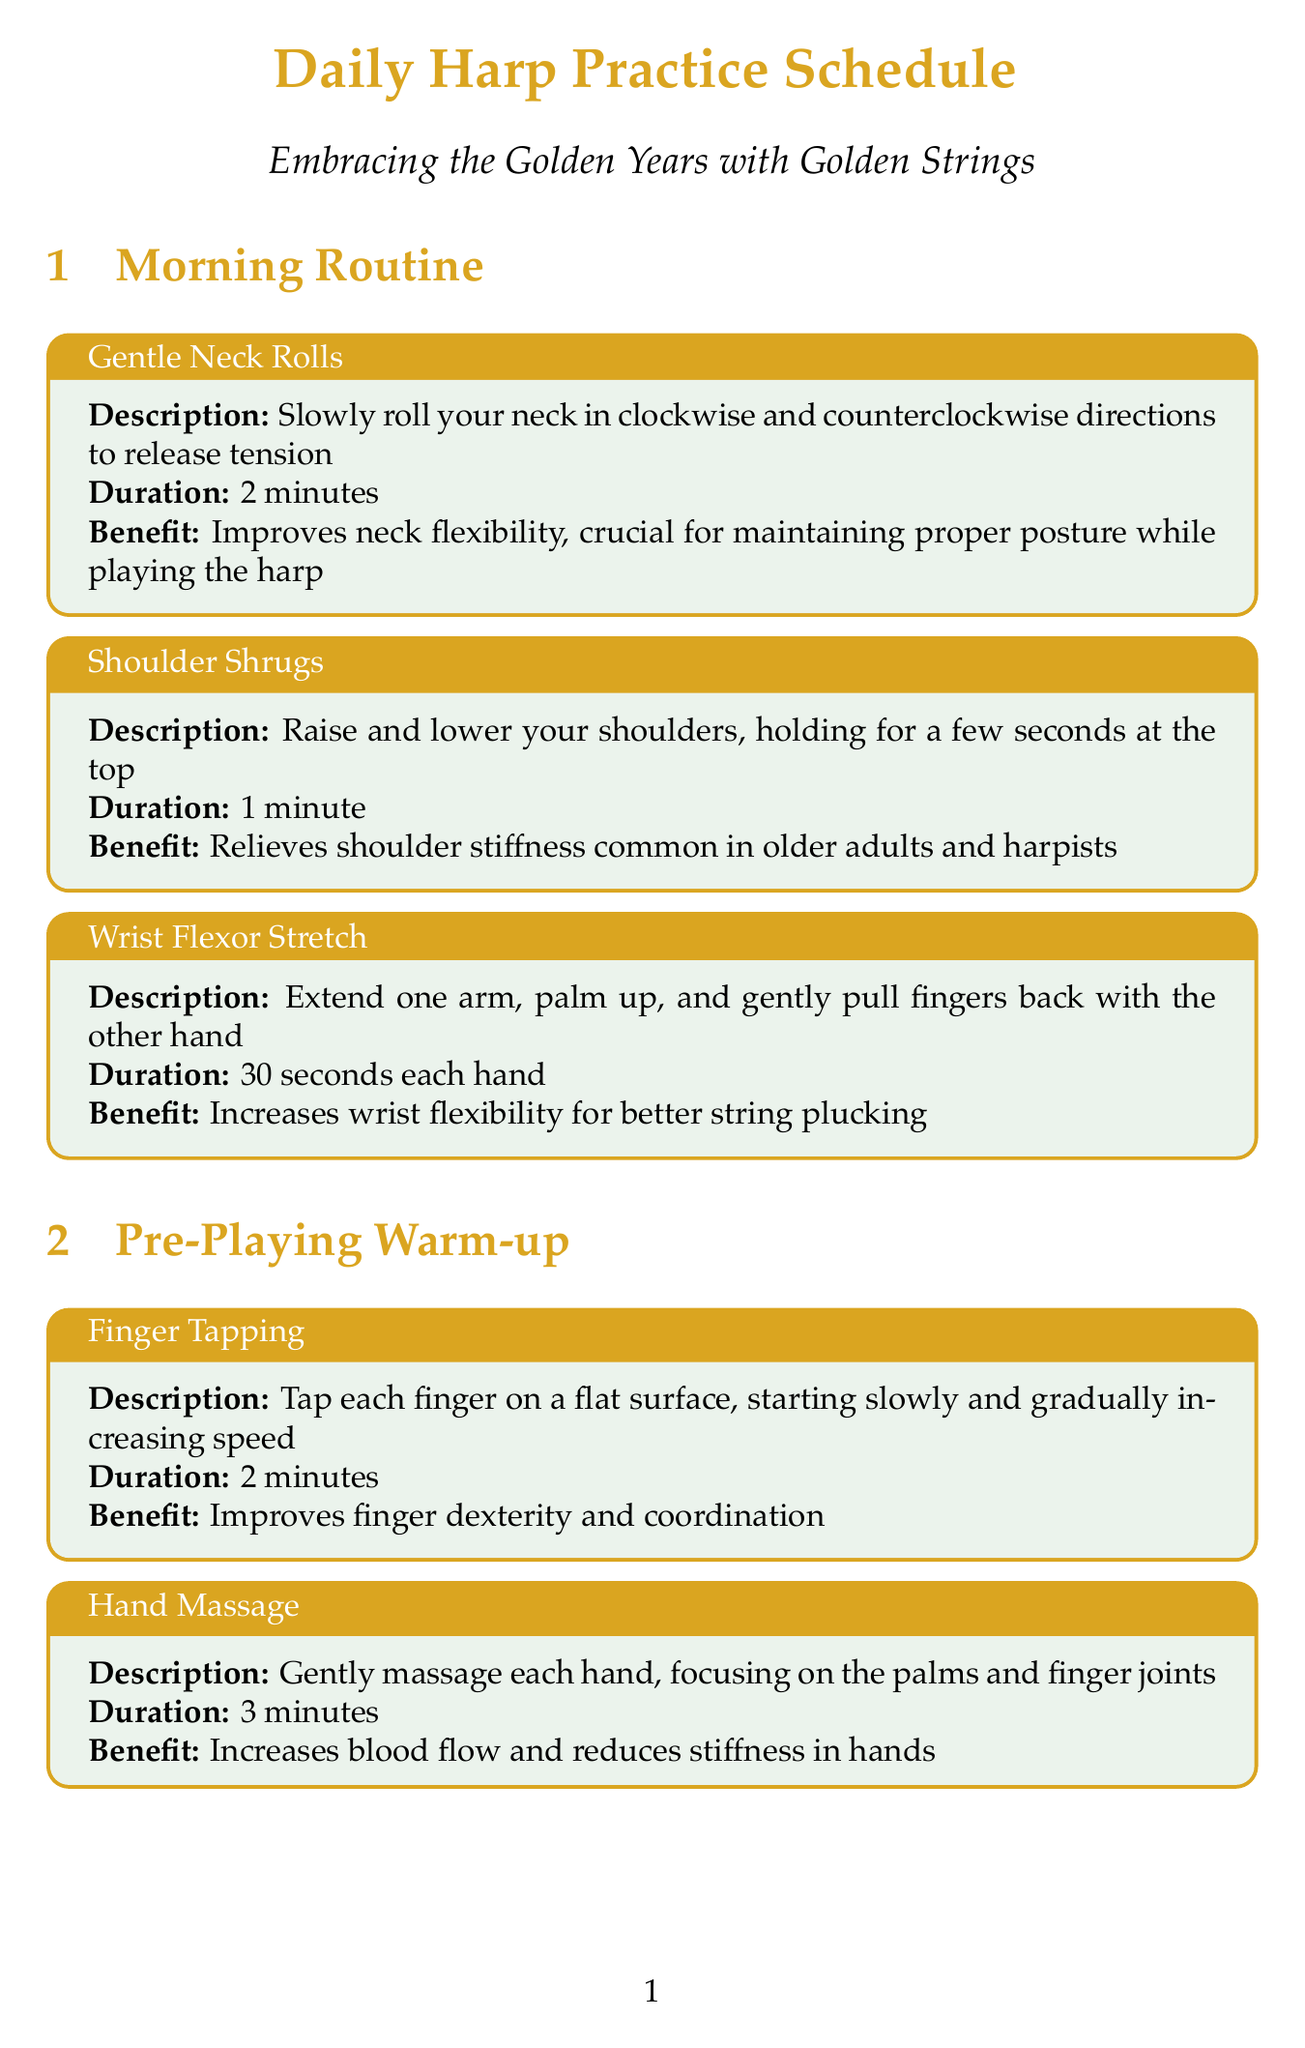What is the duration of Shoulder Shrugs? The document provides specific durations for each exercise, and Shoulder Shrugs have a duration of 1 minute.
Answer: 1 minute What exercise improves neck flexibility? The document lists various exercises and specifically mentions Gentle Neck Rolls as improving neck flexibility.
Answer: Gentle Neck Rolls How many minutes are dedicated to Salzedo Conditioning Exercises? The document states that Salzedo Conditioning Exercises take 10 minutes to practice.
Answer: 10 minutes What is the benefit of Finger Tapping? The benefit of Finger Tapping is listed as improving finger dexterity and coordination in the document.
Answer: Improves finger dexterity and coordination Which routine includes Deep Breathing Exercise? The document identifies the section titled Mental Preparation, which includes Deep Breathing Exercise.
Answer: Mental Preparation What is the description of the Grip Strength Exercise? The document provides a description detailing that it involves squeezing a soft stress ball or hand gripper.
Answer: Squeeze a soft stress ball or hand gripper How long does the cooldown exercise Finger Interlacing last? According to the document, Finger Interlacing has a specified duration of 1 minute.
Answer: 1 minute What is the total duration of the daily maintenance exercises? The daily maintenance exercises are Tai Chi Hand Movements for 5 minutes and Grip Strength Exercise for 2 minutes each hand, leading to a total of 9 minutes (5 + 2 + 2).
Answer: 9 minutes What type of exercises are included in the Harp-Specific Exercises section? The document mentions Salzedo Conditioning Exercises and Renié Arpeggios, which are designed to improve harp playing skills.
Answer: Salzedo Conditioning Exercises and Renié Arpeggios 